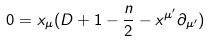<formula> <loc_0><loc_0><loc_500><loc_500>0 = x _ { \mu } ( D + 1 - \frac { n } { 2 } - x ^ { \mu ^ { \prime } } \partial _ { \mu ^ { \prime } } )</formula> 